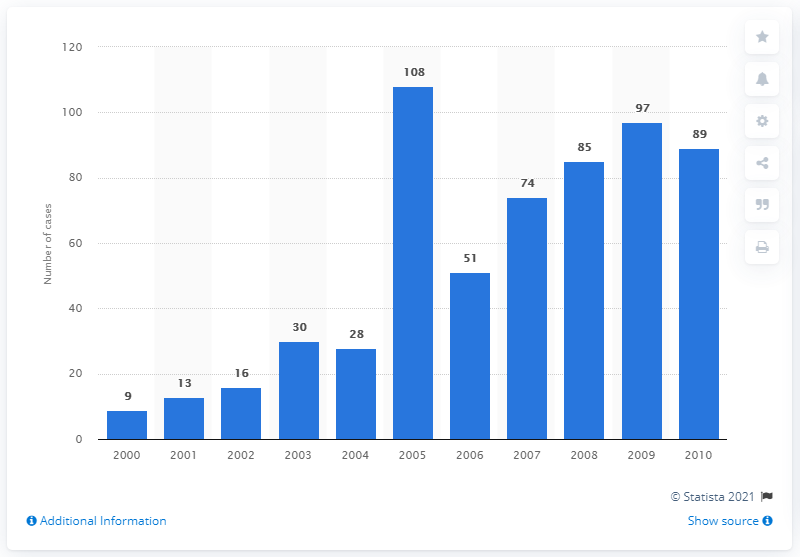Indicate a few pertinent items in this graphic. There were 9 doping cases in North America in 2000. 